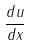<formula> <loc_0><loc_0><loc_500><loc_500>\frac { d u } { d x }</formula> 